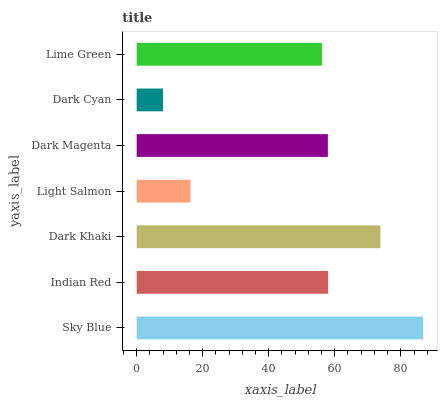Is Dark Cyan the minimum?
Answer yes or no. Yes. Is Sky Blue the maximum?
Answer yes or no. Yes. Is Indian Red the minimum?
Answer yes or no. No. Is Indian Red the maximum?
Answer yes or no. No. Is Sky Blue greater than Indian Red?
Answer yes or no. Yes. Is Indian Red less than Sky Blue?
Answer yes or no. Yes. Is Indian Red greater than Sky Blue?
Answer yes or no. No. Is Sky Blue less than Indian Red?
Answer yes or no. No. Is Dark Magenta the high median?
Answer yes or no. Yes. Is Dark Magenta the low median?
Answer yes or no. Yes. Is Indian Red the high median?
Answer yes or no. No. Is Light Salmon the low median?
Answer yes or no. No. 